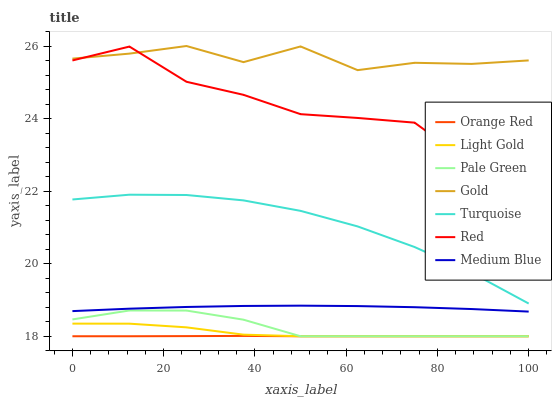Does Medium Blue have the minimum area under the curve?
Answer yes or no. No. Does Medium Blue have the maximum area under the curve?
Answer yes or no. No. Is Gold the smoothest?
Answer yes or no. No. Is Gold the roughest?
Answer yes or no. No. Does Medium Blue have the lowest value?
Answer yes or no. No. Does Medium Blue have the highest value?
Answer yes or no. No. Is Medium Blue less than Turquoise?
Answer yes or no. Yes. Is Turquoise greater than Pale Green?
Answer yes or no. Yes. Does Medium Blue intersect Turquoise?
Answer yes or no. No. 